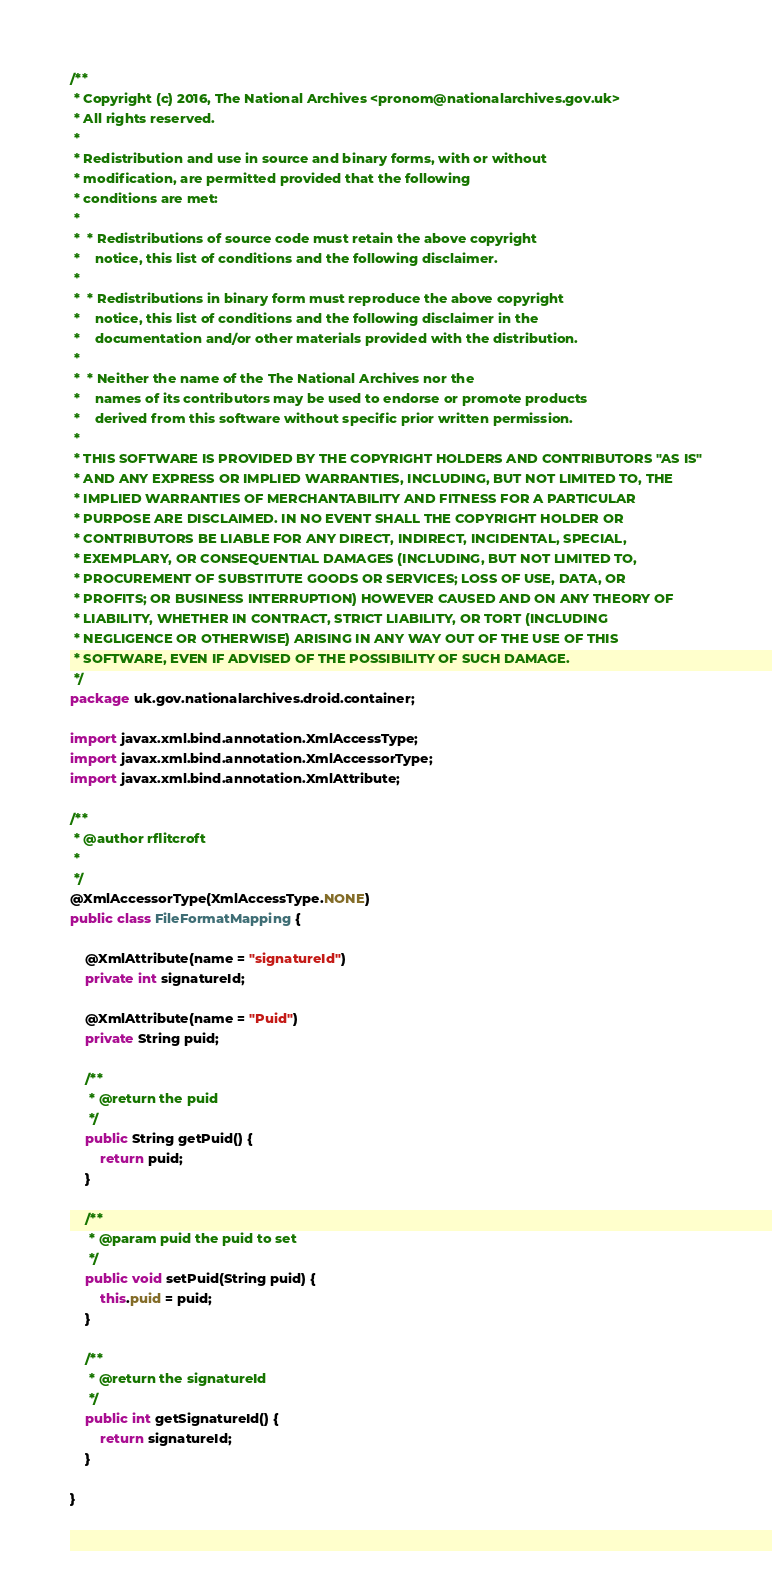<code> <loc_0><loc_0><loc_500><loc_500><_Java_>/**
 * Copyright (c) 2016, The National Archives <pronom@nationalarchives.gov.uk>
 * All rights reserved.
 *
 * Redistribution and use in source and binary forms, with or without
 * modification, are permitted provided that the following
 * conditions are met:
 *
 *  * Redistributions of source code must retain the above copyright
 *    notice, this list of conditions and the following disclaimer.
 *
 *  * Redistributions in binary form must reproduce the above copyright
 *    notice, this list of conditions and the following disclaimer in the
 *    documentation and/or other materials provided with the distribution.
 *
 *  * Neither the name of the The National Archives nor the
 *    names of its contributors may be used to endorse or promote products
 *    derived from this software without specific prior written permission.
 *
 * THIS SOFTWARE IS PROVIDED BY THE COPYRIGHT HOLDERS AND CONTRIBUTORS "AS IS"
 * AND ANY EXPRESS OR IMPLIED WARRANTIES, INCLUDING, BUT NOT LIMITED TO, THE
 * IMPLIED WARRANTIES OF MERCHANTABILITY AND FITNESS FOR A PARTICULAR
 * PURPOSE ARE DISCLAIMED. IN NO EVENT SHALL THE COPYRIGHT HOLDER OR
 * CONTRIBUTORS BE LIABLE FOR ANY DIRECT, INDIRECT, INCIDENTAL, SPECIAL,
 * EXEMPLARY, OR CONSEQUENTIAL DAMAGES (INCLUDING, BUT NOT LIMITED TO,
 * PROCUREMENT OF SUBSTITUTE GOODS OR SERVICES; LOSS OF USE, DATA, OR
 * PROFITS; OR BUSINESS INTERRUPTION) HOWEVER CAUSED AND ON ANY THEORY OF
 * LIABILITY, WHETHER IN CONTRACT, STRICT LIABILITY, OR TORT (INCLUDING
 * NEGLIGENCE OR OTHERWISE) ARISING IN ANY WAY OUT OF THE USE OF THIS
 * SOFTWARE, EVEN IF ADVISED OF THE POSSIBILITY OF SUCH DAMAGE.
 */
package uk.gov.nationalarchives.droid.container;

import javax.xml.bind.annotation.XmlAccessType;
import javax.xml.bind.annotation.XmlAccessorType;
import javax.xml.bind.annotation.XmlAttribute;

/**
 * @author rflitcroft
 *
 */
@XmlAccessorType(XmlAccessType.NONE)
public class FileFormatMapping {

    @XmlAttribute(name = "signatureId")
    private int signatureId;
    
    @XmlAttribute(name = "Puid")
    private String puid;

    /**
     * @return the puid
     */
    public String getPuid() {
        return puid;
    }
    
    /**
     * @param puid the puid to set
     */
    public void setPuid(String puid) {
        this.puid = puid;
    }
    
    /**
     * @return the signatureId
     */
    public int getSignatureId() {
        return signatureId;
    }
    
}
</code> 